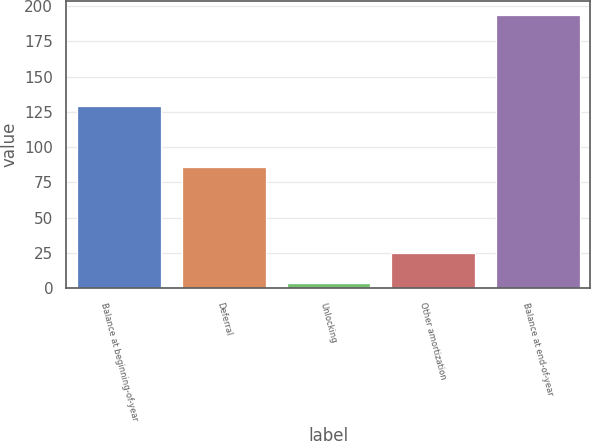Convert chart. <chart><loc_0><loc_0><loc_500><loc_500><bar_chart><fcel>Balance at beginning-of-year<fcel>Deferral<fcel>Unlocking<fcel>Other amortization<fcel>Balance at end-of-year<nl><fcel>129<fcel>86<fcel>4<fcel>25<fcel>194<nl></chart> 